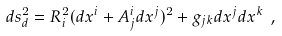<formula> <loc_0><loc_0><loc_500><loc_500>d s _ { d } ^ { 2 } = R _ { i } ^ { 2 } ( d x ^ { i } + A _ { j } ^ { i } d x ^ { j } ) ^ { 2 } + g _ { j k } d x ^ { j } d x ^ { k } \ ,</formula> 